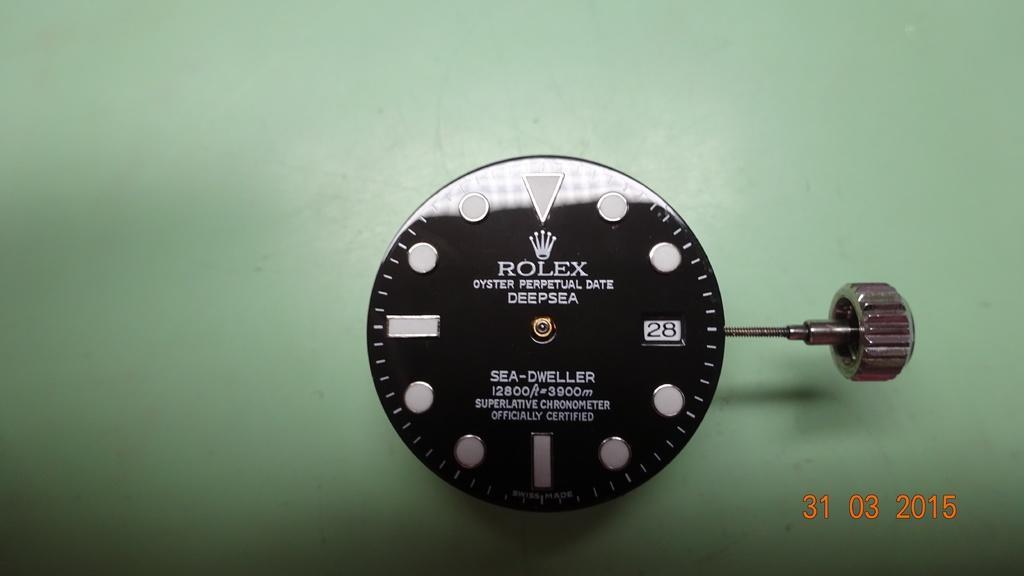How would you summarize this image in a sentence or two? In this image, we can see the dial of a watch on the surface. We can also see the knob. 